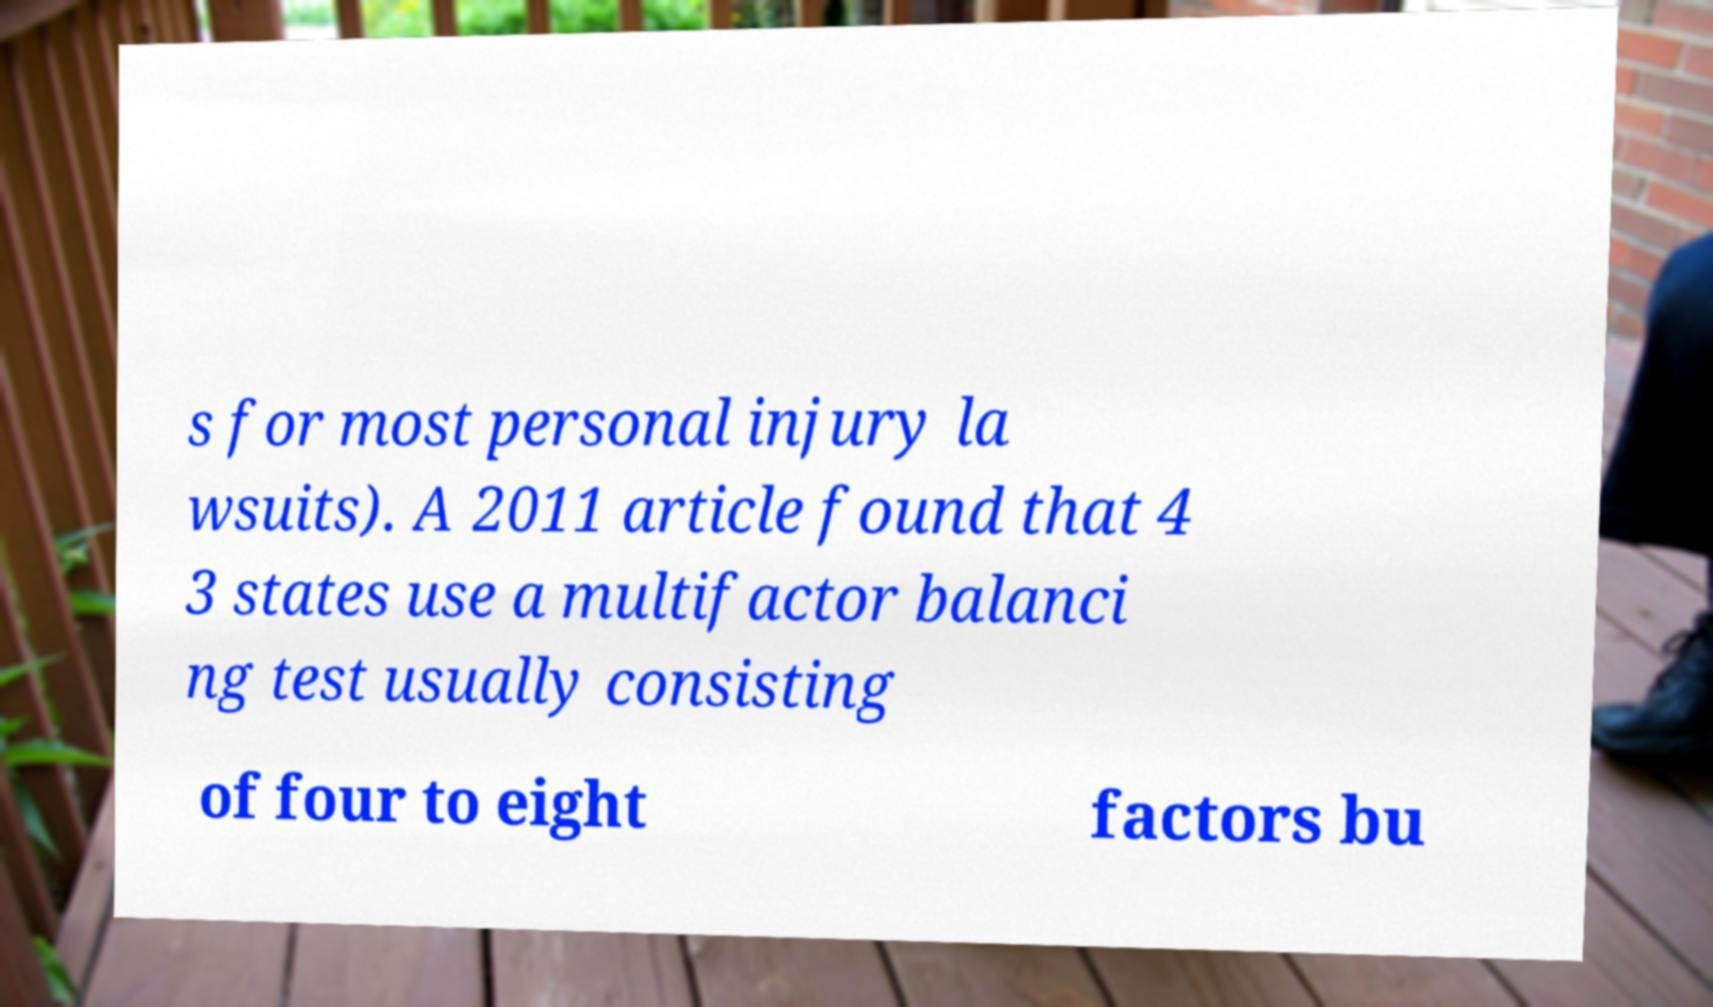Please read and relay the text visible in this image. What does it say? s for most personal injury la wsuits). A 2011 article found that 4 3 states use a multifactor balanci ng test usually consisting of four to eight factors bu 